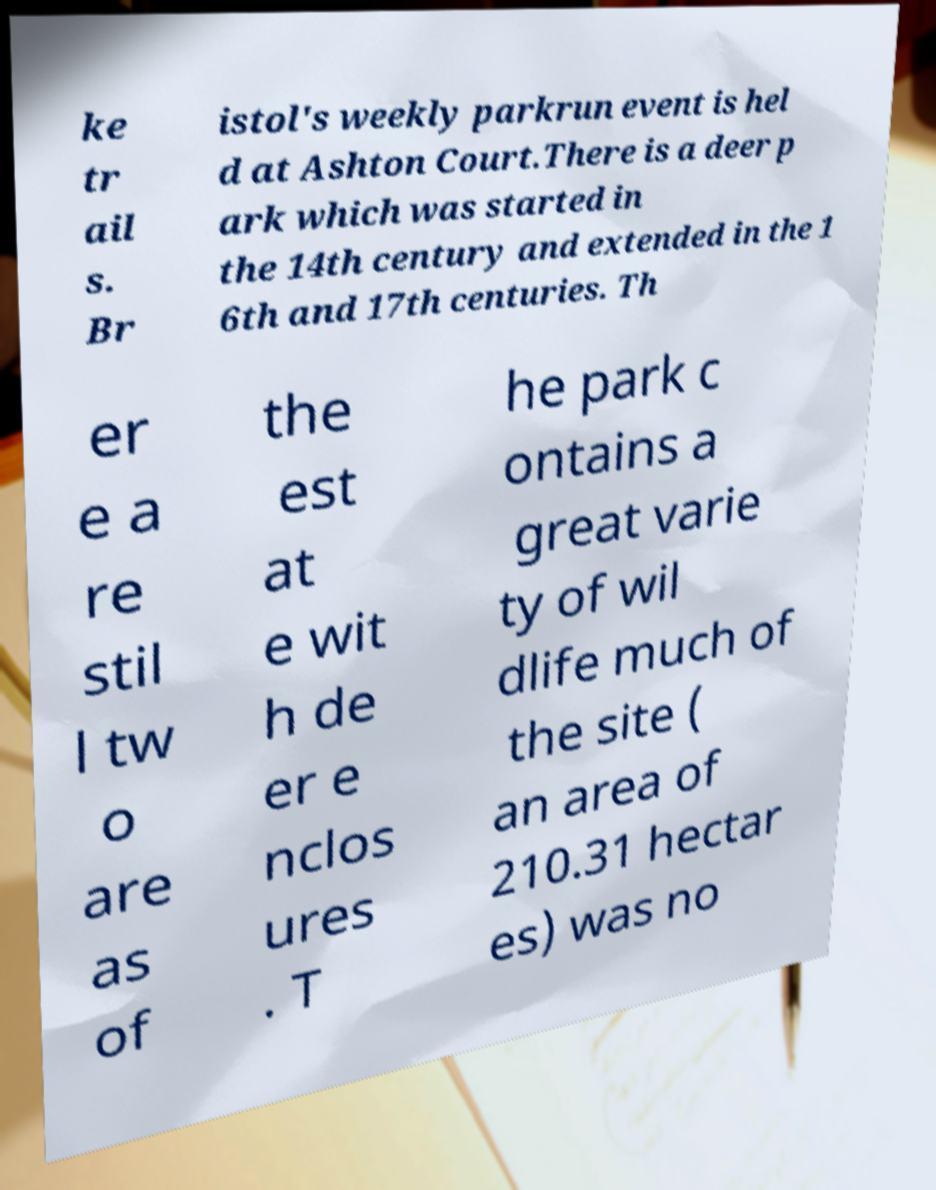What messages or text are displayed in this image? I need them in a readable, typed format. ke tr ail s. Br istol's weekly parkrun event is hel d at Ashton Court.There is a deer p ark which was started in the 14th century and extended in the 1 6th and 17th centuries. Th er e a re stil l tw o are as of the est at e wit h de er e nclos ures . T he park c ontains a great varie ty of wil dlife much of the site ( an area of 210.31 hectar es) was no 